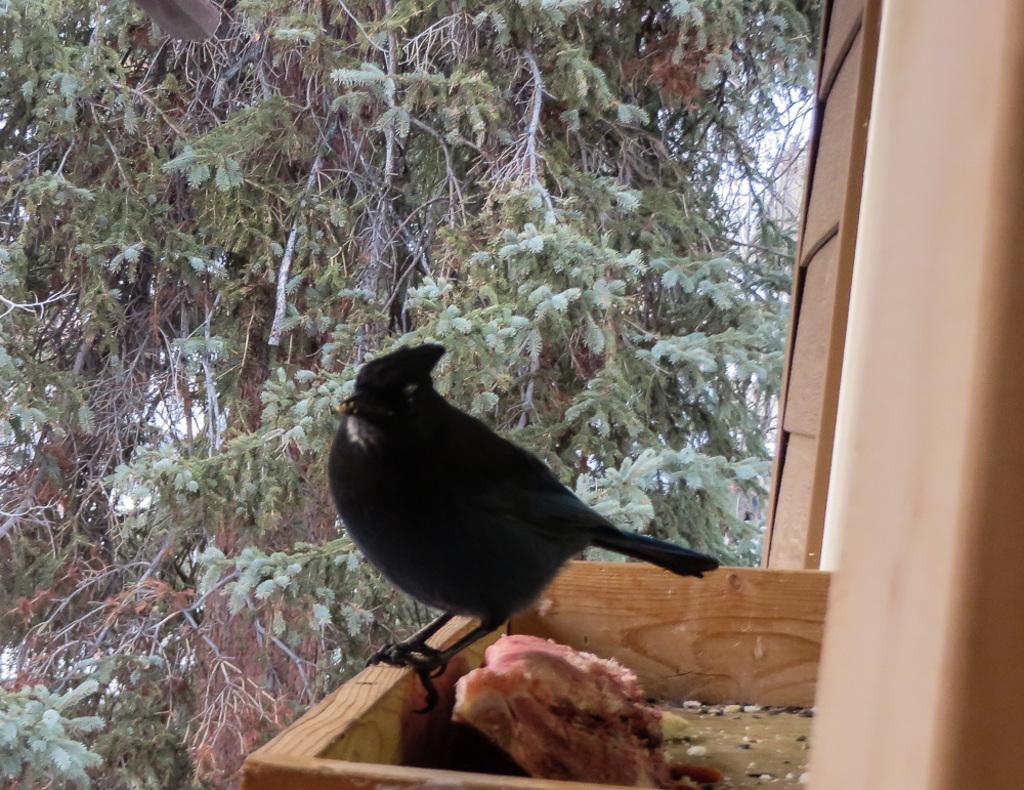Describe this image in one or two sentences. In the center of the image we can see a bird and there is a food placed in the wooden box. In the background there is a tree. On the right we can see a wooden wall. 